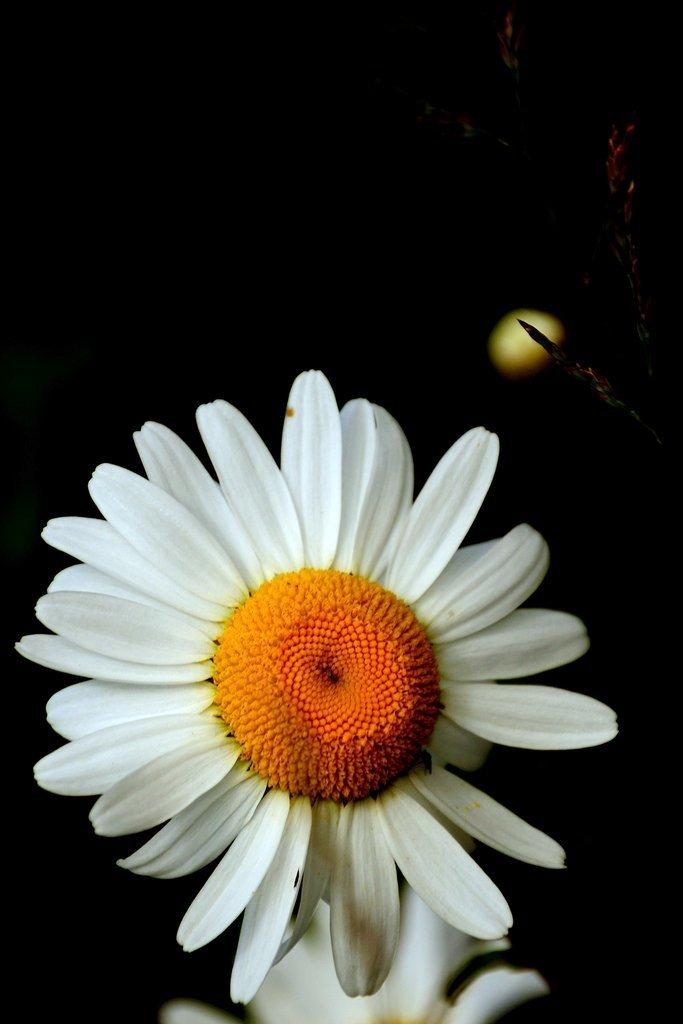What type of flower can be seen in the image? There is a white color flower in the image. How would you describe the background of the image? The background of the image is dark. Is there any part of the image that appears blurred? Yes, the bottom of the image is slightly blurred. Can you identify any other flowers in the image? Another flower is visible in the blurred area at the bottom of the image. How does the donkey react to the flower in the image? There is no donkey present in the image, so it is not possible to determine its reaction to the flower. 